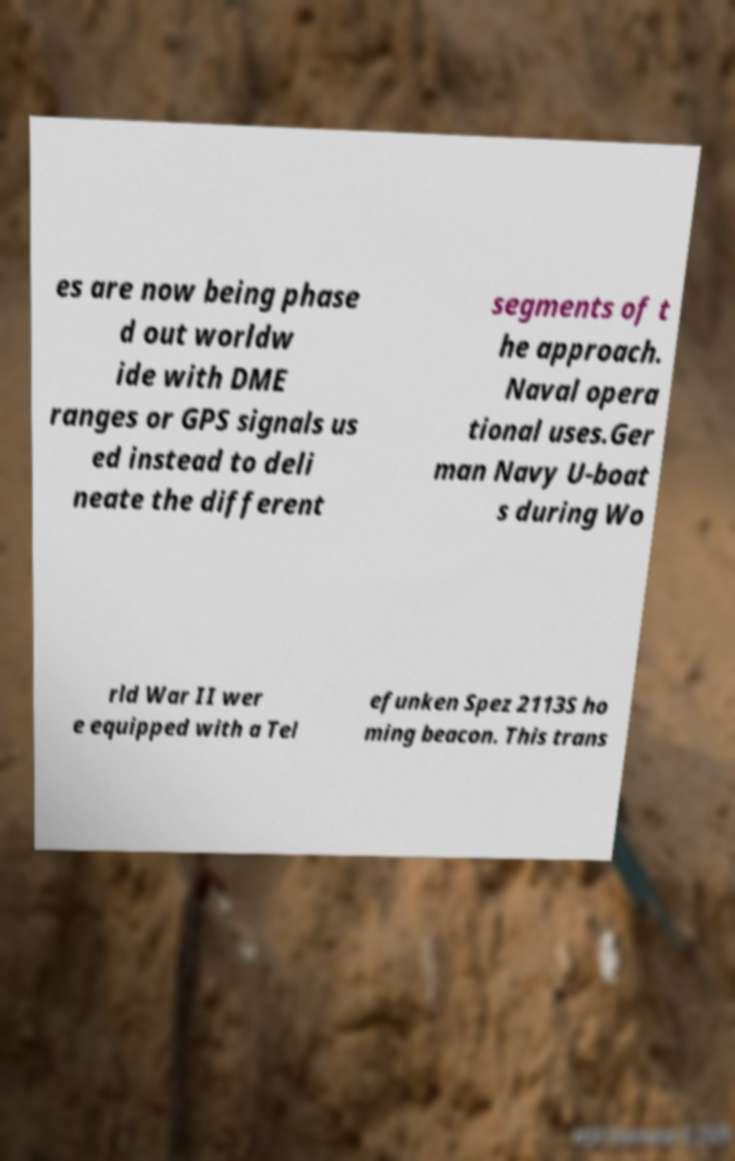Please identify and transcribe the text found in this image. es are now being phase d out worldw ide with DME ranges or GPS signals us ed instead to deli neate the different segments of t he approach. Naval opera tional uses.Ger man Navy U-boat s during Wo rld War II wer e equipped with a Tel efunken Spez 2113S ho ming beacon. This trans 